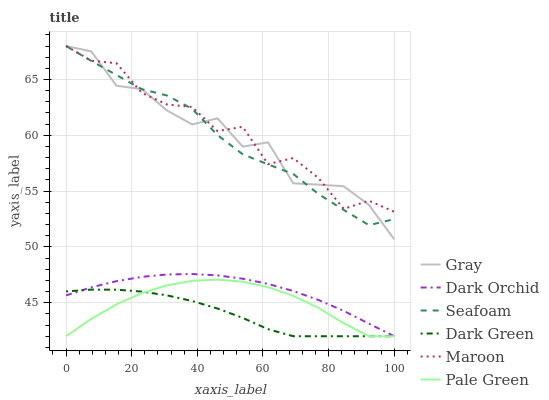Does Dark Green have the minimum area under the curve?
Answer yes or no. Yes. Does Maroon have the maximum area under the curve?
Answer yes or no. Yes. Does Seafoam have the minimum area under the curve?
Answer yes or no. No. Does Seafoam have the maximum area under the curve?
Answer yes or no. No. Is Dark Orchid the smoothest?
Answer yes or no. Yes. Is Maroon the roughest?
Answer yes or no. Yes. Is Seafoam the smoothest?
Answer yes or no. No. Is Seafoam the roughest?
Answer yes or no. No. Does Pale Green have the lowest value?
Answer yes or no. Yes. Does Seafoam have the lowest value?
Answer yes or no. No. Does Maroon have the highest value?
Answer yes or no. Yes. Does Pale Green have the highest value?
Answer yes or no. No. Is Pale Green less than Gray?
Answer yes or no. Yes. Is Seafoam greater than Pale Green?
Answer yes or no. Yes. Does Dark Orchid intersect Pale Green?
Answer yes or no. Yes. Is Dark Orchid less than Pale Green?
Answer yes or no. No. Is Dark Orchid greater than Pale Green?
Answer yes or no. No. Does Pale Green intersect Gray?
Answer yes or no. No. 